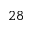<formula> <loc_0><loc_0><loc_500><loc_500>2 8</formula> 